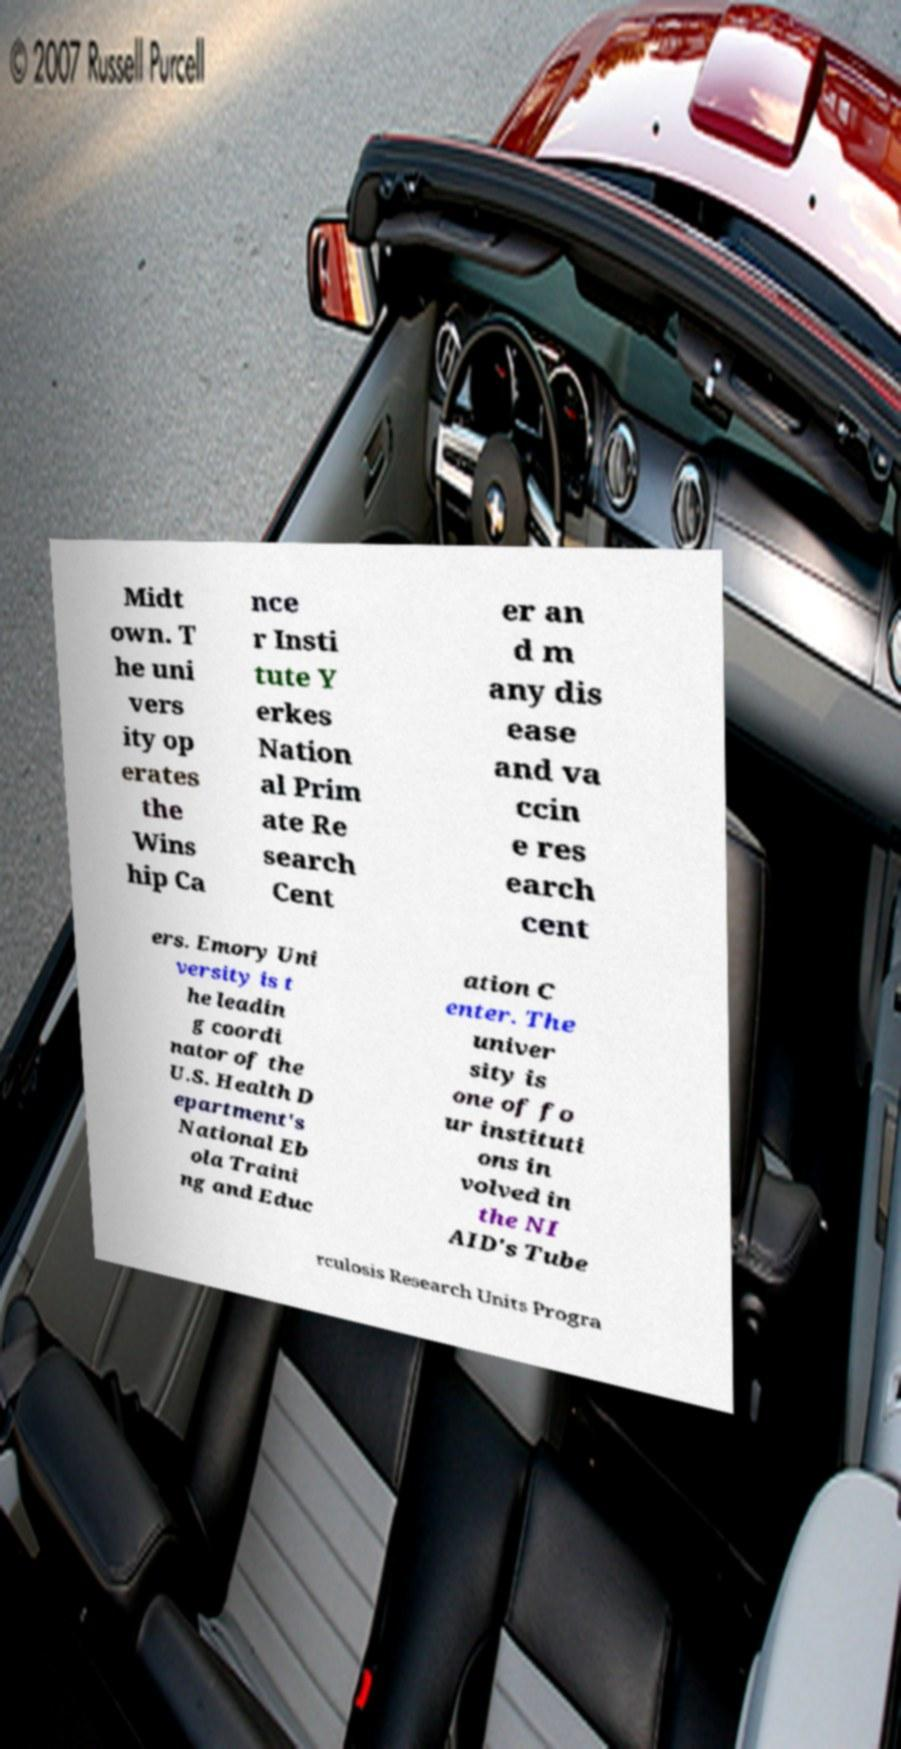Could you assist in decoding the text presented in this image and type it out clearly? Midt own. T he uni vers ity op erates the Wins hip Ca nce r Insti tute Y erkes Nation al Prim ate Re search Cent er an d m any dis ease and va ccin e res earch cent ers. Emory Uni versity is t he leadin g coordi nator of the U.S. Health D epartment's National Eb ola Traini ng and Educ ation C enter. The univer sity is one of fo ur instituti ons in volved in the NI AID's Tube rculosis Research Units Progra 